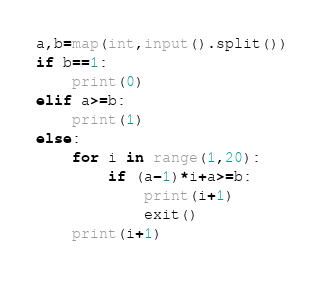<code> <loc_0><loc_0><loc_500><loc_500><_Python_>a,b=map(int,input().split())
if b==1:
    print(0)
elif a>=b:
    print(1)
else:
    for i in range(1,20):
        if (a-1)*i+a>=b:
            print(i+1)
            exit()
    print(i+1)

</code> 